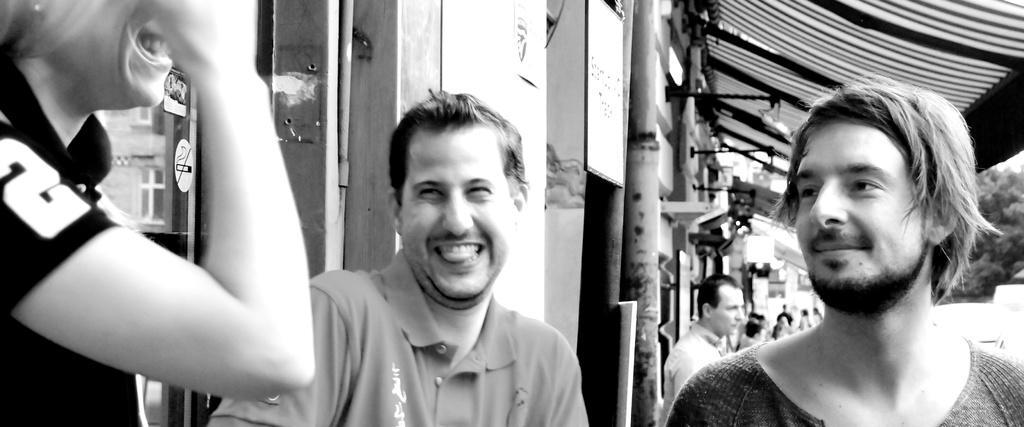Could you give a brief overview of what you see in this image? We can see people and we can see wall and board on pole. Background we can see trees. 